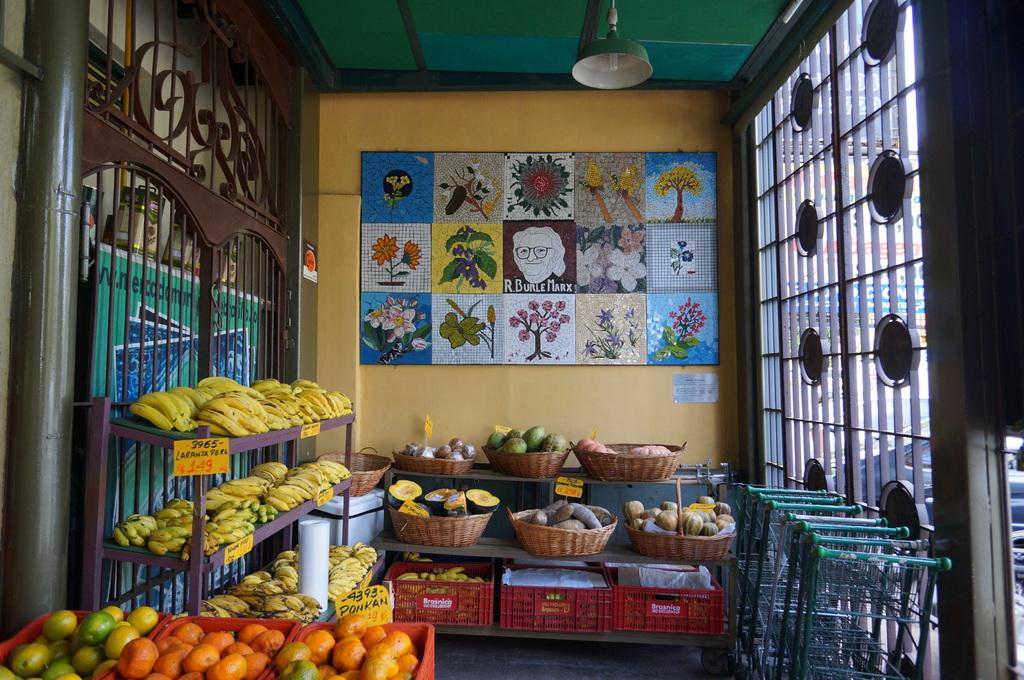What type of fruit can be seen in the image? There are bananas in the image, which are a type of fruit. What can be inferred about the variety of fruits in the image? Since there are fruits in baskets, crates, and on shelves, it suggests that there is a variety of fruits present. What is attached to the wall in the image? There are boards attached to the wall in the image. What can be seen through the windows in the image? The presence of windows in the image suggests that there is a view outside, but the specific view cannot be determined from the facts provided. What type of lighting is present in the image? There is a light on the ceiling in the image. What type of sand can be seen on the floor in the image? There is no sand present on the floor in the image. 